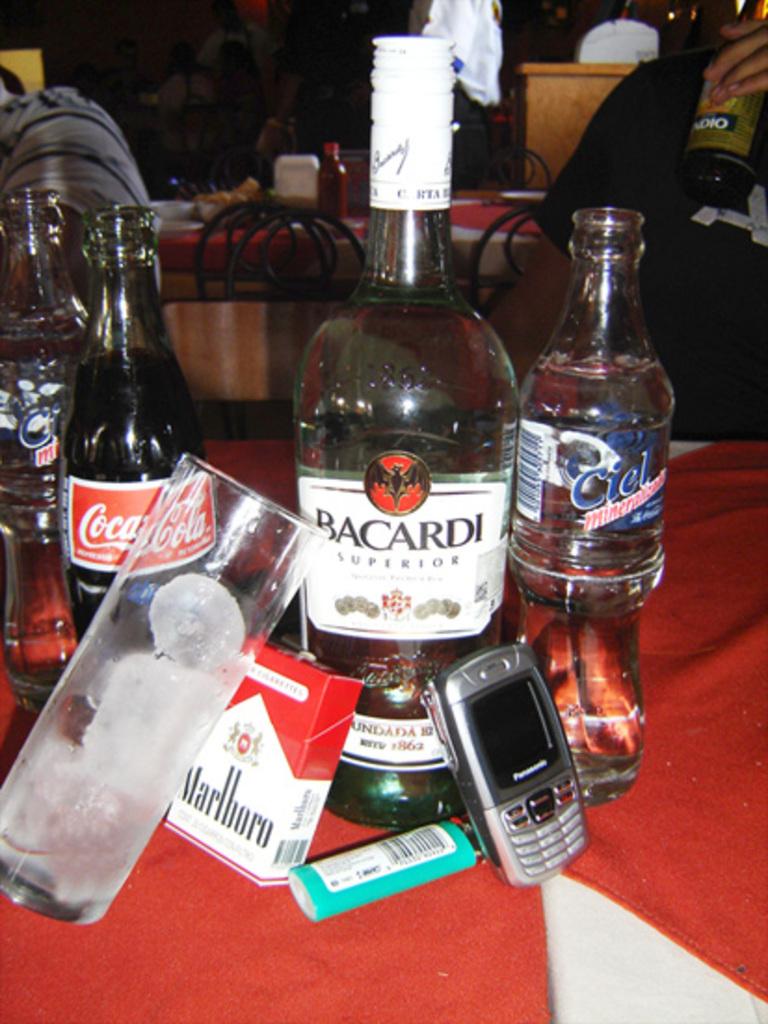Does this person mix the coca cola and bacardi?
Offer a terse response. Answering does not require reading text in the image. What brand of cigarettes is on the table?
Make the answer very short. Marlboro. 